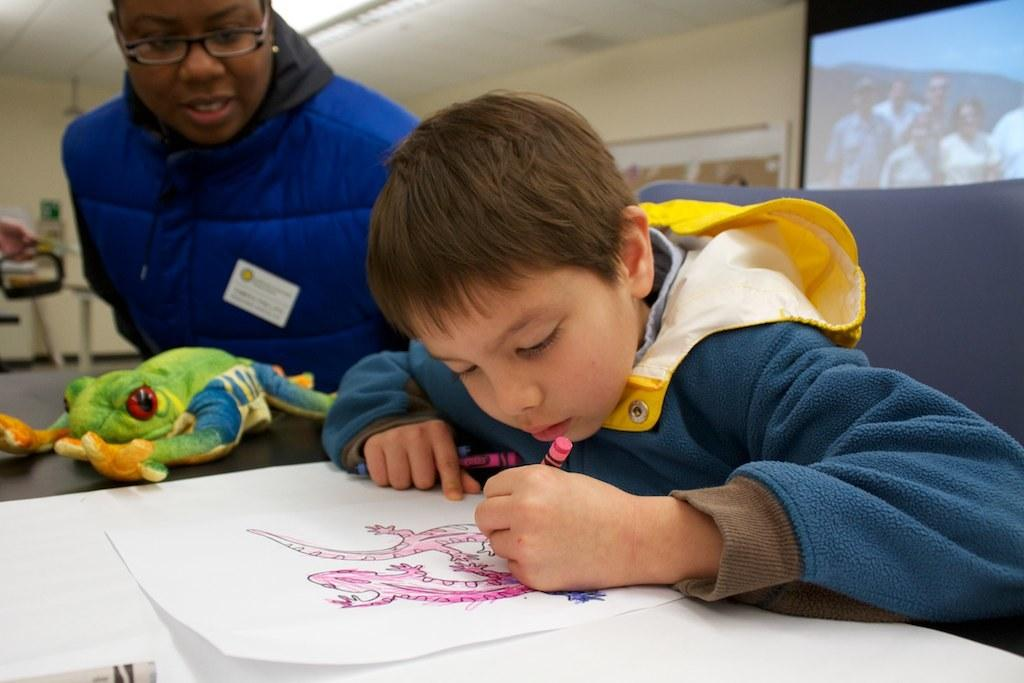What is the boy in the image doing? The boy is drawing in the image. Who is with the boy in the image? There is a person beside the boy in the image. What is the person wearing? The person is wearing a coat. What can be seen on the wall or screen in the image? There is a projector display in the image. What type of sand can be seen in the image? There is no sand present in the image. How many screws are visible in the image? There are no screws visible in the image. 